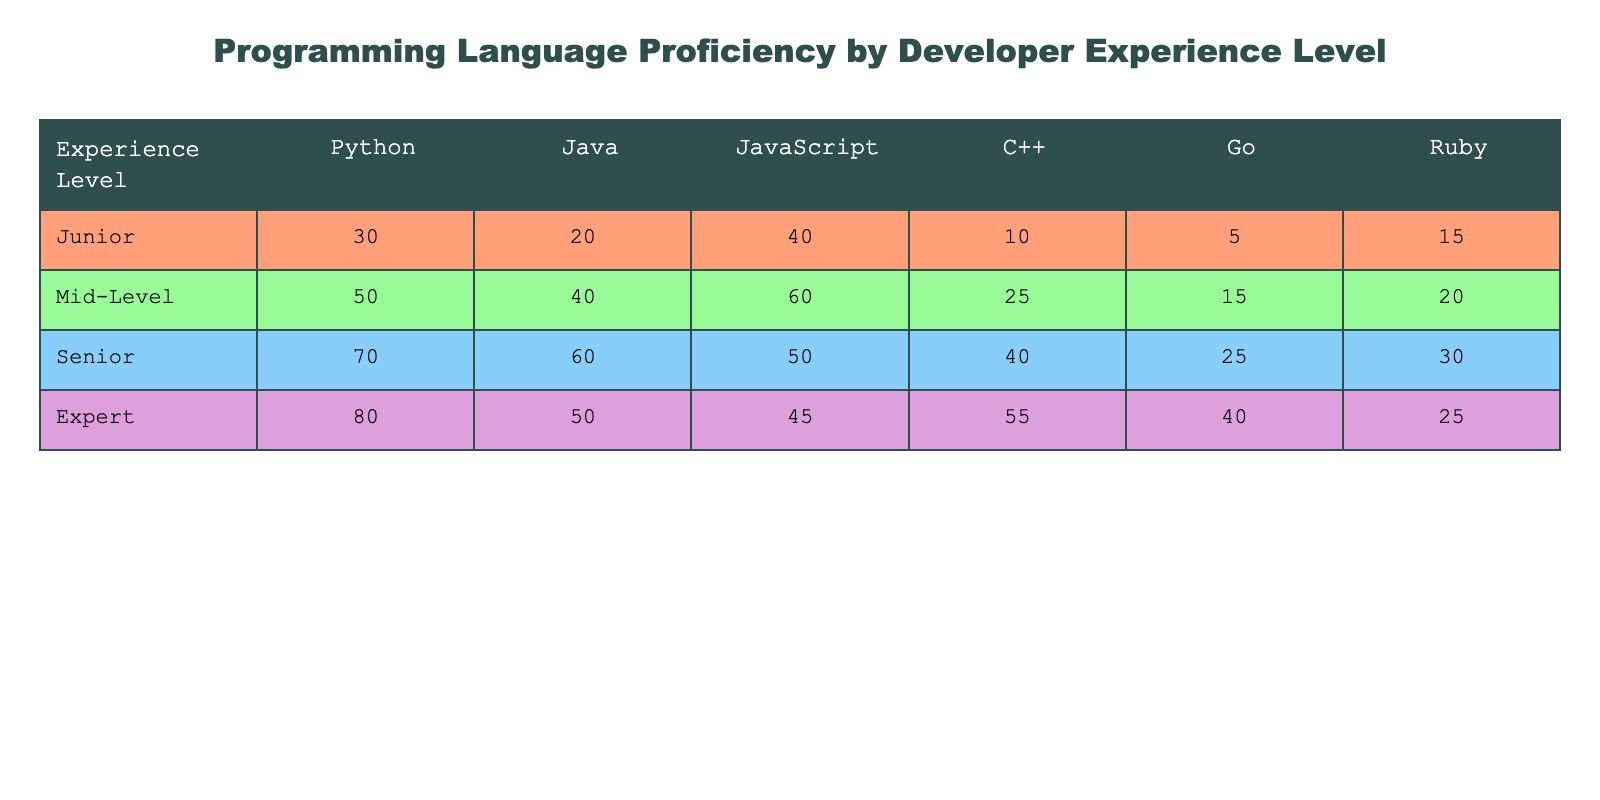What is the proficiency level of juniors in Python? The table shows that juniors have a proficiency level of 30 in Python.
Answer: 30 Which programming language has the highest proficiency among mid-level developers? For mid-level developers, JavaScript has the highest proficiency at 60, compared to other languages listed (Python 50, Java 40, C++ 25, Go 15, Ruby 20).
Answer: JavaScript What is the total proficiency score for senior developers across all languages? To find the total, we sum the senior developers' scores: (70 + 60 + 50 + 40 + 25 + 30) = 275.
Answer: 275 Is there a programming language in which expert developers scored less than 30? According to the table, expert developers never scored below 25 in any language (the lowest is Ruby with a score of 25).
Answer: No What is the average proficiency in Java for all experience levels? To calculate the average for Java: (20 + 40 + 60 + 50)/4 = 42.5. Therefore, the average proficiency in Java is 42.5.
Answer: 42.5 Which programming language shows the largest growth in proficiency from junior to expert levels? Analyzing the data, Python increases from 30 (junior) to 80 (expert), showing a growth of 50 points. The other languages are: Java (20 to 50: +30), JavaScript (40 to 45: +5), C++ (10 to 55: +45), Go (5 to 40: +35), and Ruby (15 to 25: +10). Thus, Python shows the largest growth of 50.
Answer: Python How does the proficiency of juniors in Java compare to that of seniors in the same language? Juniors have a proficiency of 20 in Java, whereas seniors have a proficiency of 60. Thus, seniors are more proficient in Java than juniors.
Answer: Seniors are more proficient What is the difference in proficiency between mid-level developers and seniors in C++? Mid-level developers have a proficiency of 25 in C++, while seniors have 40. The difference is calculated as 40 - 25 = 15.
Answer: 15 How many developers are proficient in Go at the expert level compared to juniors? At the expert level, the proficiency in Go is 40, while for juniors it's only 5. Thus, 35 more developers are proficient in Go at the expert level than at the junior level.
Answer: 35 